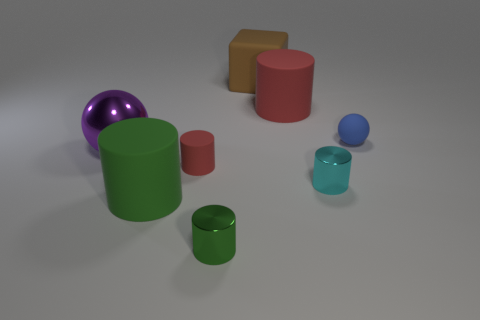What shape is the tiny object that is the same material as the tiny sphere?
Your answer should be compact. Cylinder. The red object that is the same size as the green metal cylinder is what shape?
Your response must be concise. Cylinder. Are there an equal number of metallic things to the left of the tiny green shiny cylinder and small rubber objects in front of the purple shiny sphere?
Give a very brief answer. Yes. Is there anything else that is the same shape as the brown thing?
Provide a succinct answer. No. Do the ball left of the large brown thing and the big green thing have the same material?
Offer a terse response. No. There is a red cylinder that is the same size as the cyan shiny thing; what is it made of?
Offer a very short reply. Rubber. How many other things are made of the same material as the purple object?
Provide a short and direct response. 2. Is the size of the brown block the same as the red matte object that is behind the large purple sphere?
Ensure brevity in your answer.  Yes. Are there fewer big rubber things that are to the left of the block than objects left of the tiny cyan shiny thing?
Provide a succinct answer. Yes. What is the size of the cylinder that is behind the large shiny object?
Make the answer very short. Large. 